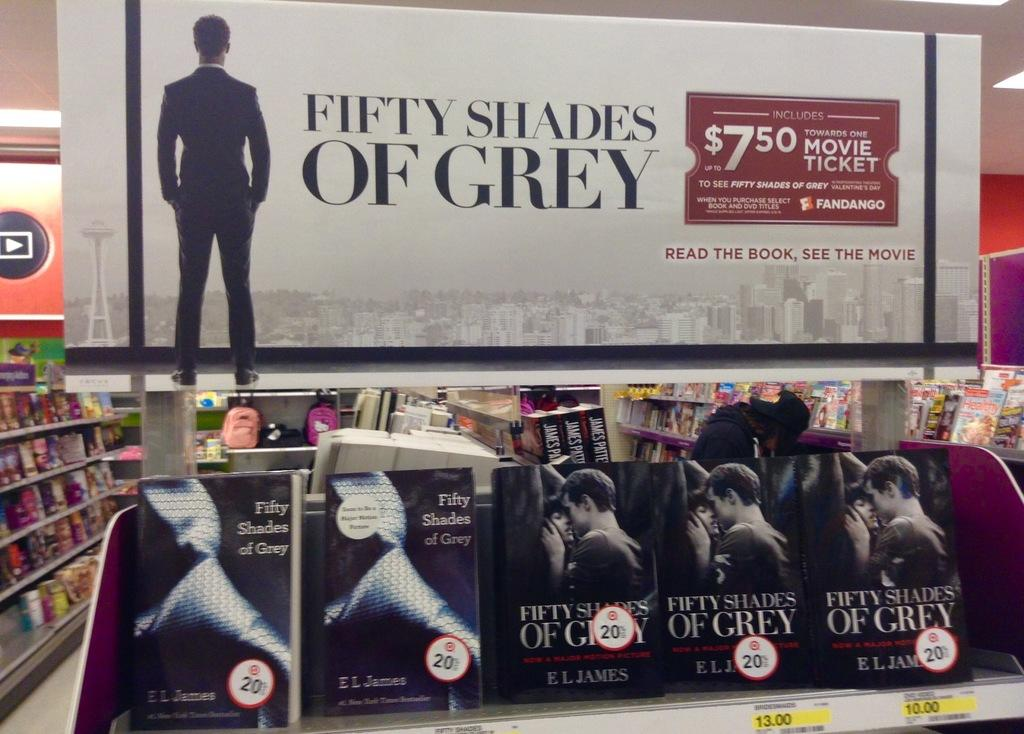<image>
Provide a brief description of the given image. Fifty Shades of Grey books being put out for sale. 